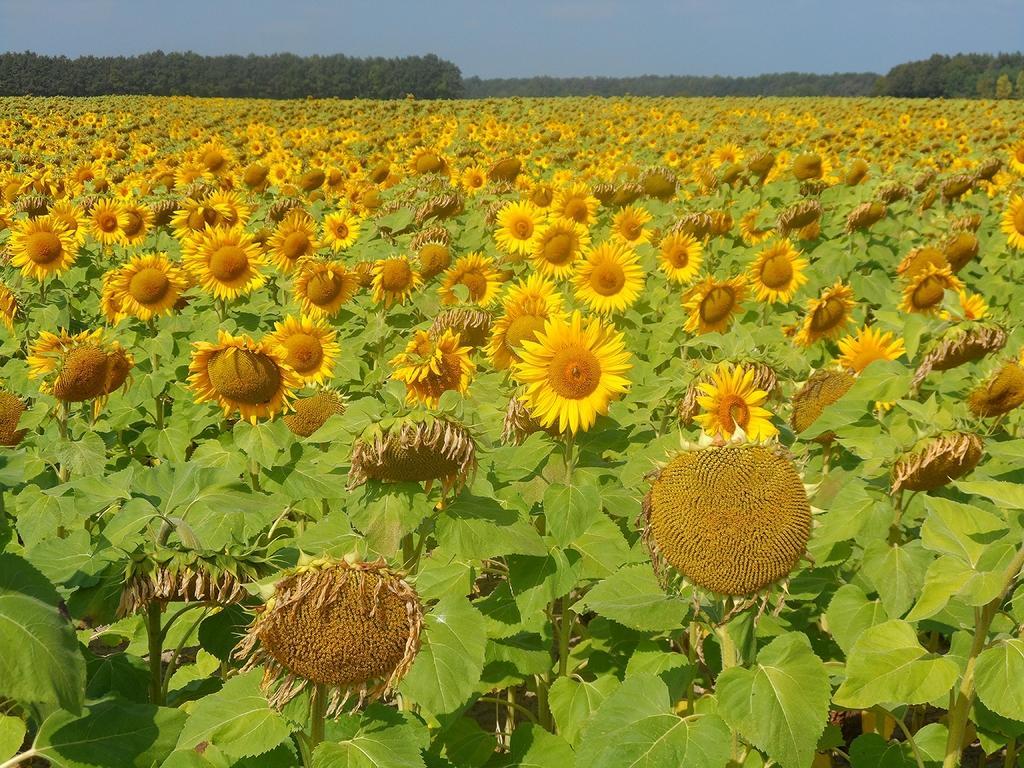Describe this image in one or two sentences. In this image I can see sunflower plants, trees and the sky. This image is taken in a farm during a day. 